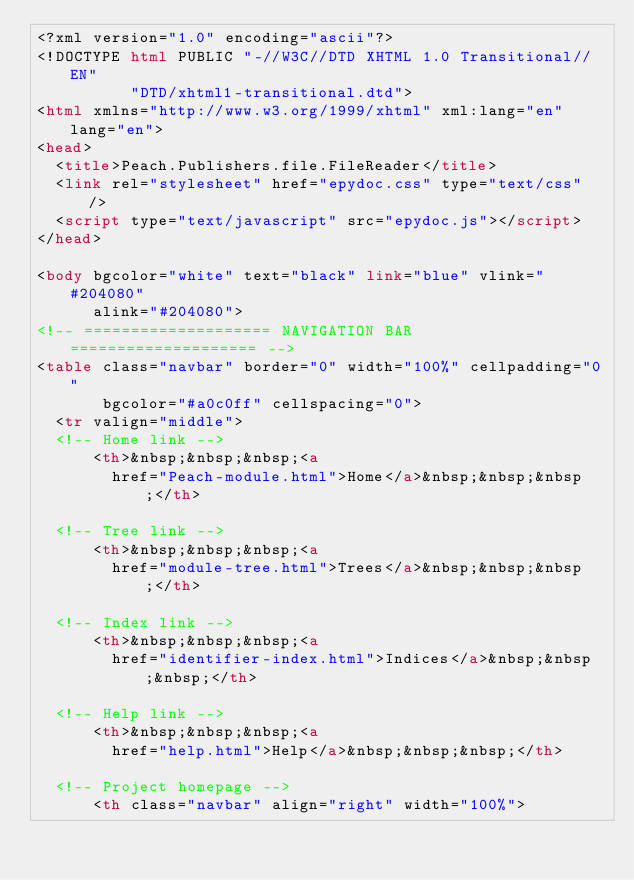Convert code to text. <code><loc_0><loc_0><loc_500><loc_500><_HTML_><?xml version="1.0" encoding="ascii"?>
<!DOCTYPE html PUBLIC "-//W3C//DTD XHTML 1.0 Transitional//EN"
          "DTD/xhtml1-transitional.dtd">
<html xmlns="http://www.w3.org/1999/xhtml" xml:lang="en" lang="en">
<head>
  <title>Peach.Publishers.file.FileReader</title>
  <link rel="stylesheet" href="epydoc.css" type="text/css" />
  <script type="text/javascript" src="epydoc.js"></script>
</head>

<body bgcolor="white" text="black" link="blue" vlink="#204080"
      alink="#204080">
<!-- ==================== NAVIGATION BAR ==================== -->
<table class="navbar" border="0" width="100%" cellpadding="0"
       bgcolor="#a0c0ff" cellspacing="0">
  <tr valign="middle">
  <!-- Home link -->
      <th>&nbsp;&nbsp;&nbsp;<a
        href="Peach-module.html">Home</a>&nbsp;&nbsp;&nbsp;</th>

  <!-- Tree link -->
      <th>&nbsp;&nbsp;&nbsp;<a
        href="module-tree.html">Trees</a>&nbsp;&nbsp;&nbsp;</th>

  <!-- Index link -->
      <th>&nbsp;&nbsp;&nbsp;<a
        href="identifier-index.html">Indices</a>&nbsp;&nbsp;&nbsp;</th>

  <!-- Help link -->
      <th>&nbsp;&nbsp;&nbsp;<a
        href="help.html">Help</a>&nbsp;&nbsp;&nbsp;</th>

  <!-- Project homepage -->
      <th class="navbar" align="right" width="100%"></code> 